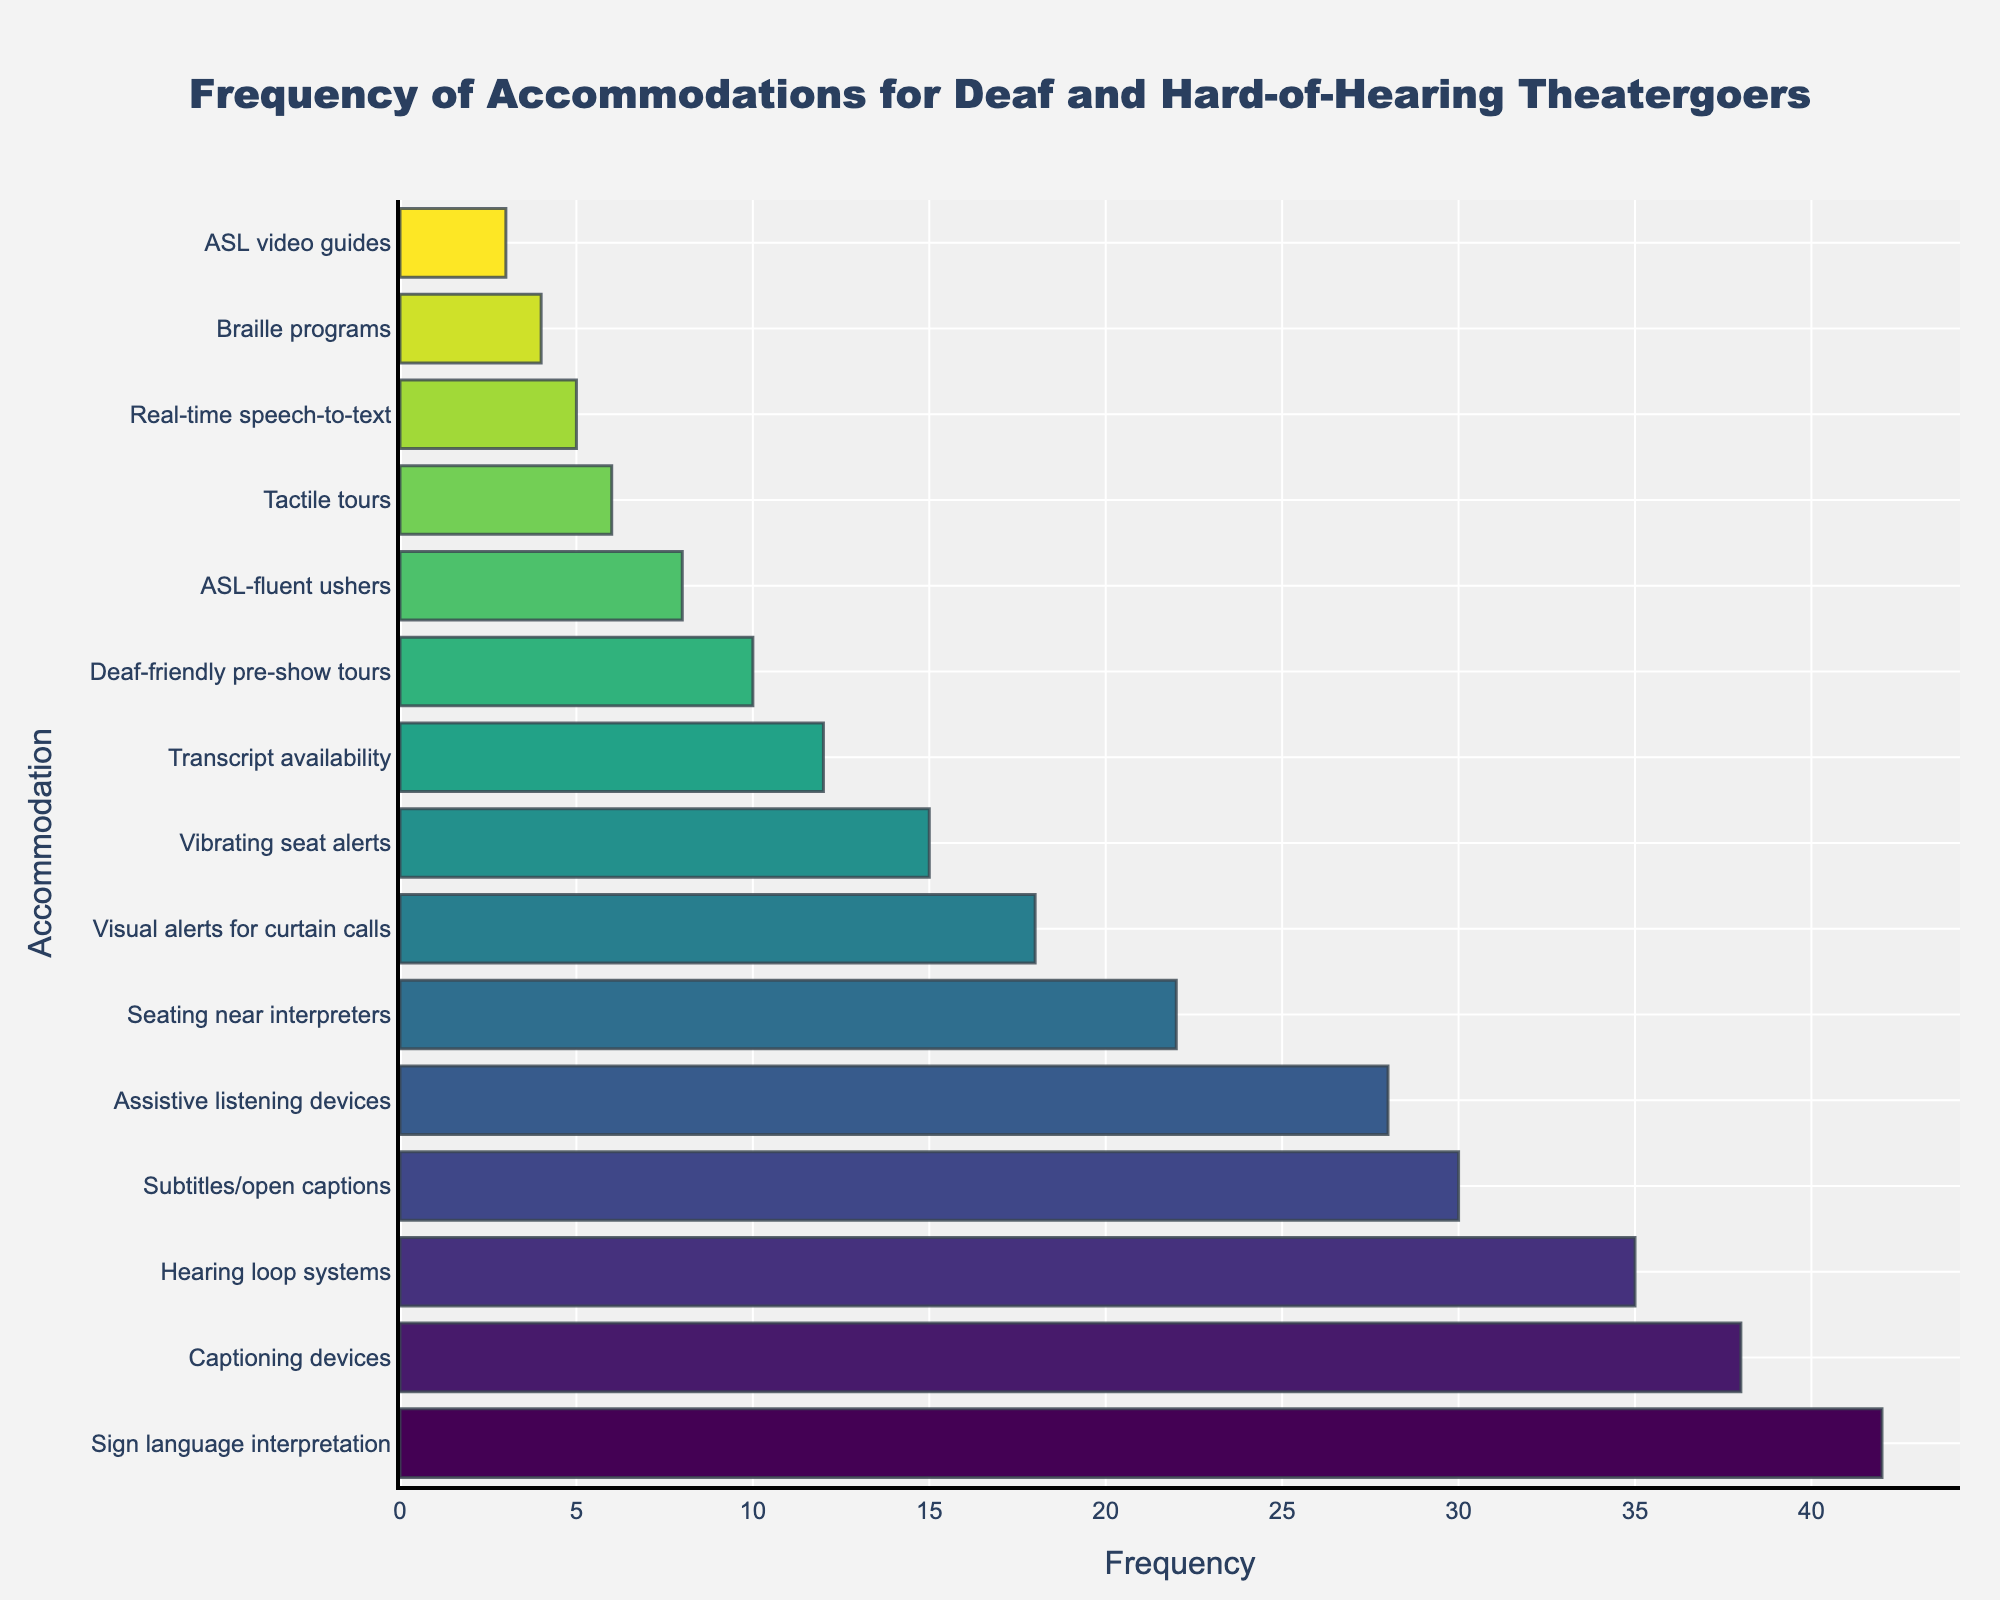Which accommodation is requested the most frequently? The bar chart shows that the accommodation with the longest bar is "Sign language interpretation," indicating it is the most requested.
Answer: Sign language interpretation Which two accommodations have the closest frequencies? By visually comparing the lengths of the bars, "Captioning devices" and "Hearing loop systems" have closely matched lengths with frequencies of 38 and 35, respectively.
Answer: Captioning devices, Hearing loop systems What is the total frequency of the three least requested accommodations? The three least requested accommodations are "ASL video guides" (3), "Braille programs" (4), and "Real-time speech-to-text" (5). Adding these, 3 + 4 + 5 = 12.
Answer: 12 Which accommodation has a higher frequency: "Subtitles/open captions" or "Assistive listening devices"? By comparing the lengths of the respective bars, "Subtitles/open captions" has a frequency of 30, whereas "Assistive listening devices" has a frequency of 28. Therefore, "Subtitles/open captions" is higher.
Answer: Subtitles/open captions What is the difference in frequency between "Visual alerts for curtain calls" and "Tactile tours"? "Visual alerts for curtain calls" has a frequency of 18 and "Tactile tours" has a frequency of 6. Subtracting these, 18 - 6 = 12.
Answer: 12 How many accommodations have a frequency of at least 30? By counting the bars that have a frequency of 30 or more, we find four accommodations: "Sign language interpretation" (42), "Captioning devices" (38), "Hearing loop systems" (35), and "Subtitles/open captions" (30).
Answer: 4 Which accommodations have a frequency lower than 10? From the bar chart, the accommodations with frequencies lower than 10 include "ASL-fluent ushers" (8), "Tactile tours" (6), "Real-time speech-to-text" (5), "Braille programs" (4), and "ASL video guides" (3).
Answer: ASL-fluent ushers, Tactile tours, Real-time speech-to-text, Braille programs, ASL video guides What is the average frequency of the top 5 most requested accommodations? The top 5 accommodations are "Sign language interpretation" (42), "Captioning devices" (38), "Hearing loop systems" (35), "Subtitles/open captions" (30), and "Assistive listening devices" (28). Sum these, 42 + 38 + 35 + 30 + 28 = 173. The average is 173/5 = 34.6.
Answer: 34.6 Which accommodation frequencies are exactly equal to each other? By observing the lengths of the bars, there are no exact matches in frequency between different accommodations.
Answer: None 